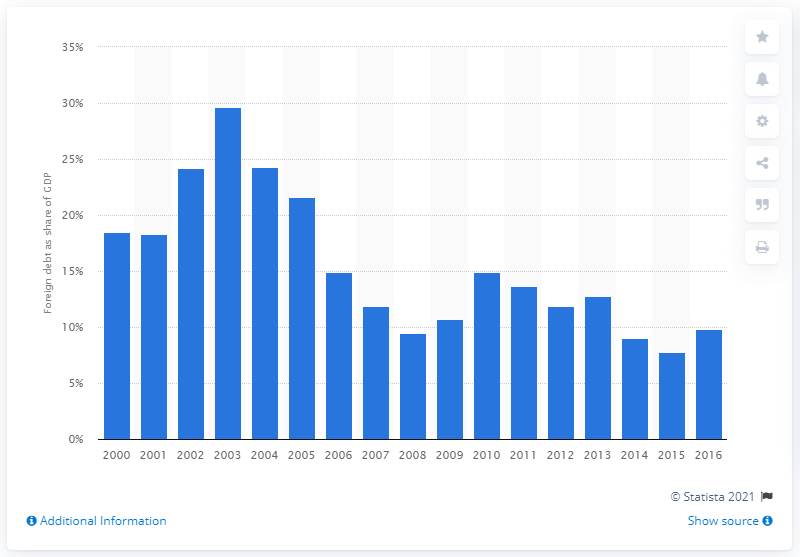Indicate a few pertinent items in this graphic. The peak of Venezuela's external debt between 2000 and 2016 was 29.6%. 